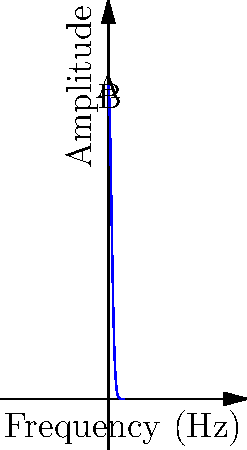As a singer-songwriter working on Todd Rundgren remixes, you're analyzing the frequency spectrum of a musical note. The amplitude (A) of the note's frequency components is modeled by the function $A(f) = 100e^{-0.5f^2}$, where $f$ is the frequency in Hz. Calculate the total energy of the note, which is proportional to the area under the curve from 0 to 5 Hz. Use the trapezoidal rule with 5 equal subintervals to approximate this area. To solve this problem, we'll follow these steps:

1) The trapezoidal rule for 5 equal subintervals is given by:

   $$\int_a^b f(x)dx \approx \frac{h}{2}[f(x_0) + 2f(x_1) + 2f(x_2) + 2f(x_3) + 2f(x_4) + f(x_5)]$$

   where $h = \frac{b-a}{n}$, $n$ is the number of subintervals, and $x_i = a + ih$.

2) In our case, $a=0$, $b=5$, $n=5$, so $h = \frac{5-0}{5} = 1$.

3) We need to calculate $f(x_i)$ for $i = 0, 1, 2, 3, 4, 5$:

   $f(0) = 100e^{-0.5(0)^2} = 100$
   $f(1) = 100e^{-0.5(1)^2} \approx 60.65$
   $f(2) = 100e^{-0.5(2)^2} \approx 13.53$
   $f(3) = 100e^{-0.5(3)^2} \approx 1.11$
   $f(4) = 100e^{-0.5(4)^2} \approx 0.03$
   $f(5) = 100e^{-0.5(5)^2} \approx 0.00$

4) Applying the trapezoidal rule:

   $$\text{Area} \approx \frac{1}{2}[100 + 2(60.65) + 2(13.53) + 2(1.11) + 2(0.03) + 0.00]$$

5) Simplifying:

   $$\text{Area} \approx \frac{1}{2}[100 + 121.30 + 27.06 + 2.22 + 0.06 + 0.00] = \frac{250.64}{2} = 125.32$$

Therefore, the approximate area under the curve from 0 to 5 Hz, representing the total energy of the note, is 125.32 units.
Answer: 125.32 units 